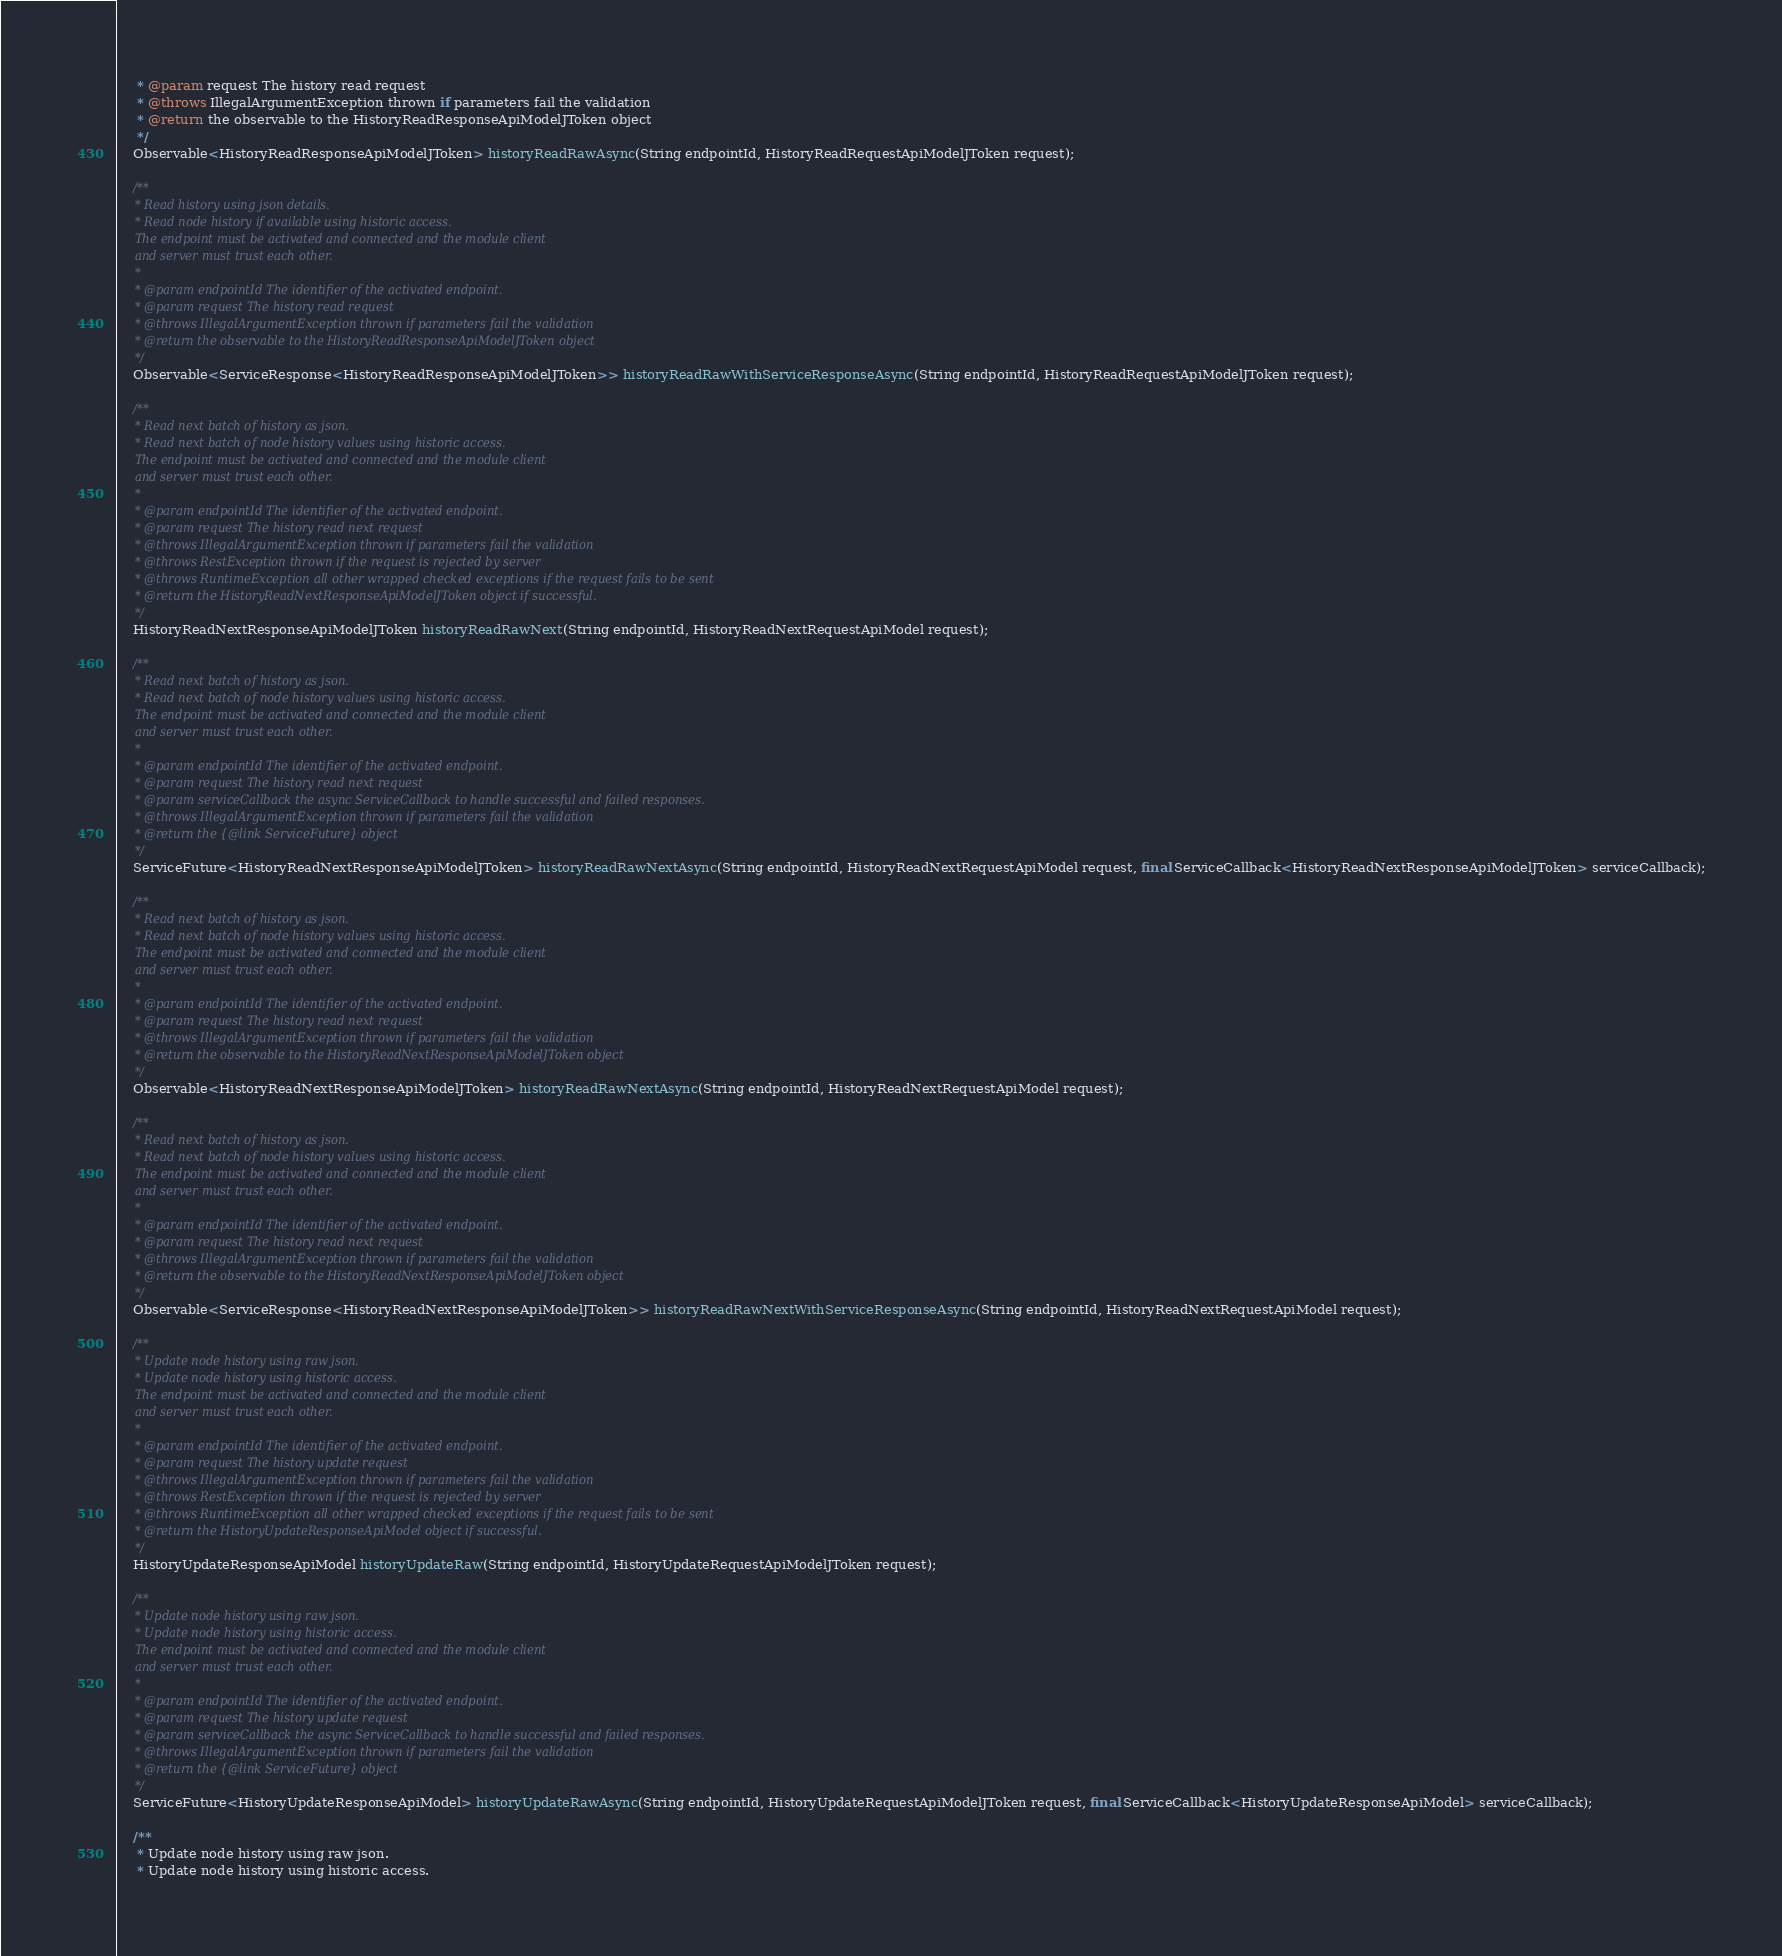<code> <loc_0><loc_0><loc_500><loc_500><_Java_>     * @param request The history read request
     * @throws IllegalArgumentException thrown if parameters fail the validation
     * @return the observable to the HistoryReadResponseApiModelJToken object
     */
    Observable<HistoryReadResponseApiModelJToken> historyReadRawAsync(String endpointId, HistoryReadRequestApiModelJToken request);

    /**
     * Read history using json details.
     * Read node history if available using historic access.
     The endpoint must be activated and connected and the module client
     and server must trust each other.
     *
     * @param endpointId The identifier of the activated endpoint.
     * @param request The history read request
     * @throws IllegalArgumentException thrown if parameters fail the validation
     * @return the observable to the HistoryReadResponseApiModelJToken object
     */
    Observable<ServiceResponse<HistoryReadResponseApiModelJToken>> historyReadRawWithServiceResponseAsync(String endpointId, HistoryReadRequestApiModelJToken request);

    /**
     * Read next batch of history as json.
     * Read next batch of node history values using historic access.
     The endpoint must be activated and connected and the module client
     and server must trust each other.
     *
     * @param endpointId The identifier of the activated endpoint.
     * @param request The history read next request
     * @throws IllegalArgumentException thrown if parameters fail the validation
     * @throws RestException thrown if the request is rejected by server
     * @throws RuntimeException all other wrapped checked exceptions if the request fails to be sent
     * @return the HistoryReadNextResponseApiModelJToken object if successful.
     */
    HistoryReadNextResponseApiModelJToken historyReadRawNext(String endpointId, HistoryReadNextRequestApiModel request);

    /**
     * Read next batch of history as json.
     * Read next batch of node history values using historic access.
     The endpoint must be activated and connected and the module client
     and server must trust each other.
     *
     * @param endpointId The identifier of the activated endpoint.
     * @param request The history read next request
     * @param serviceCallback the async ServiceCallback to handle successful and failed responses.
     * @throws IllegalArgumentException thrown if parameters fail the validation
     * @return the {@link ServiceFuture} object
     */
    ServiceFuture<HistoryReadNextResponseApiModelJToken> historyReadRawNextAsync(String endpointId, HistoryReadNextRequestApiModel request, final ServiceCallback<HistoryReadNextResponseApiModelJToken> serviceCallback);

    /**
     * Read next batch of history as json.
     * Read next batch of node history values using historic access.
     The endpoint must be activated and connected and the module client
     and server must trust each other.
     *
     * @param endpointId The identifier of the activated endpoint.
     * @param request The history read next request
     * @throws IllegalArgumentException thrown if parameters fail the validation
     * @return the observable to the HistoryReadNextResponseApiModelJToken object
     */
    Observable<HistoryReadNextResponseApiModelJToken> historyReadRawNextAsync(String endpointId, HistoryReadNextRequestApiModel request);

    /**
     * Read next batch of history as json.
     * Read next batch of node history values using historic access.
     The endpoint must be activated and connected and the module client
     and server must trust each other.
     *
     * @param endpointId The identifier of the activated endpoint.
     * @param request The history read next request
     * @throws IllegalArgumentException thrown if parameters fail the validation
     * @return the observable to the HistoryReadNextResponseApiModelJToken object
     */
    Observable<ServiceResponse<HistoryReadNextResponseApiModelJToken>> historyReadRawNextWithServiceResponseAsync(String endpointId, HistoryReadNextRequestApiModel request);

    /**
     * Update node history using raw json.
     * Update node history using historic access.
     The endpoint must be activated and connected and the module client
     and server must trust each other.
     *
     * @param endpointId The identifier of the activated endpoint.
     * @param request The history update request
     * @throws IllegalArgumentException thrown if parameters fail the validation
     * @throws RestException thrown if the request is rejected by server
     * @throws RuntimeException all other wrapped checked exceptions if the request fails to be sent
     * @return the HistoryUpdateResponseApiModel object if successful.
     */
    HistoryUpdateResponseApiModel historyUpdateRaw(String endpointId, HistoryUpdateRequestApiModelJToken request);

    /**
     * Update node history using raw json.
     * Update node history using historic access.
     The endpoint must be activated and connected and the module client
     and server must trust each other.
     *
     * @param endpointId The identifier of the activated endpoint.
     * @param request The history update request
     * @param serviceCallback the async ServiceCallback to handle successful and failed responses.
     * @throws IllegalArgumentException thrown if parameters fail the validation
     * @return the {@link ServiceFuture} object
     */
    ServiceFuture<HistoryUpdateResponseApiModel> historyUpdateRawAsync(String endpointId, HistoryUpdateRequestApiModelJToken request, final ServiceCallback<HistoryUpdateResponseApiModel> serviceCallback);

    /**
     * Update node history using raw json.
     * Update node history using historic access.</code> 